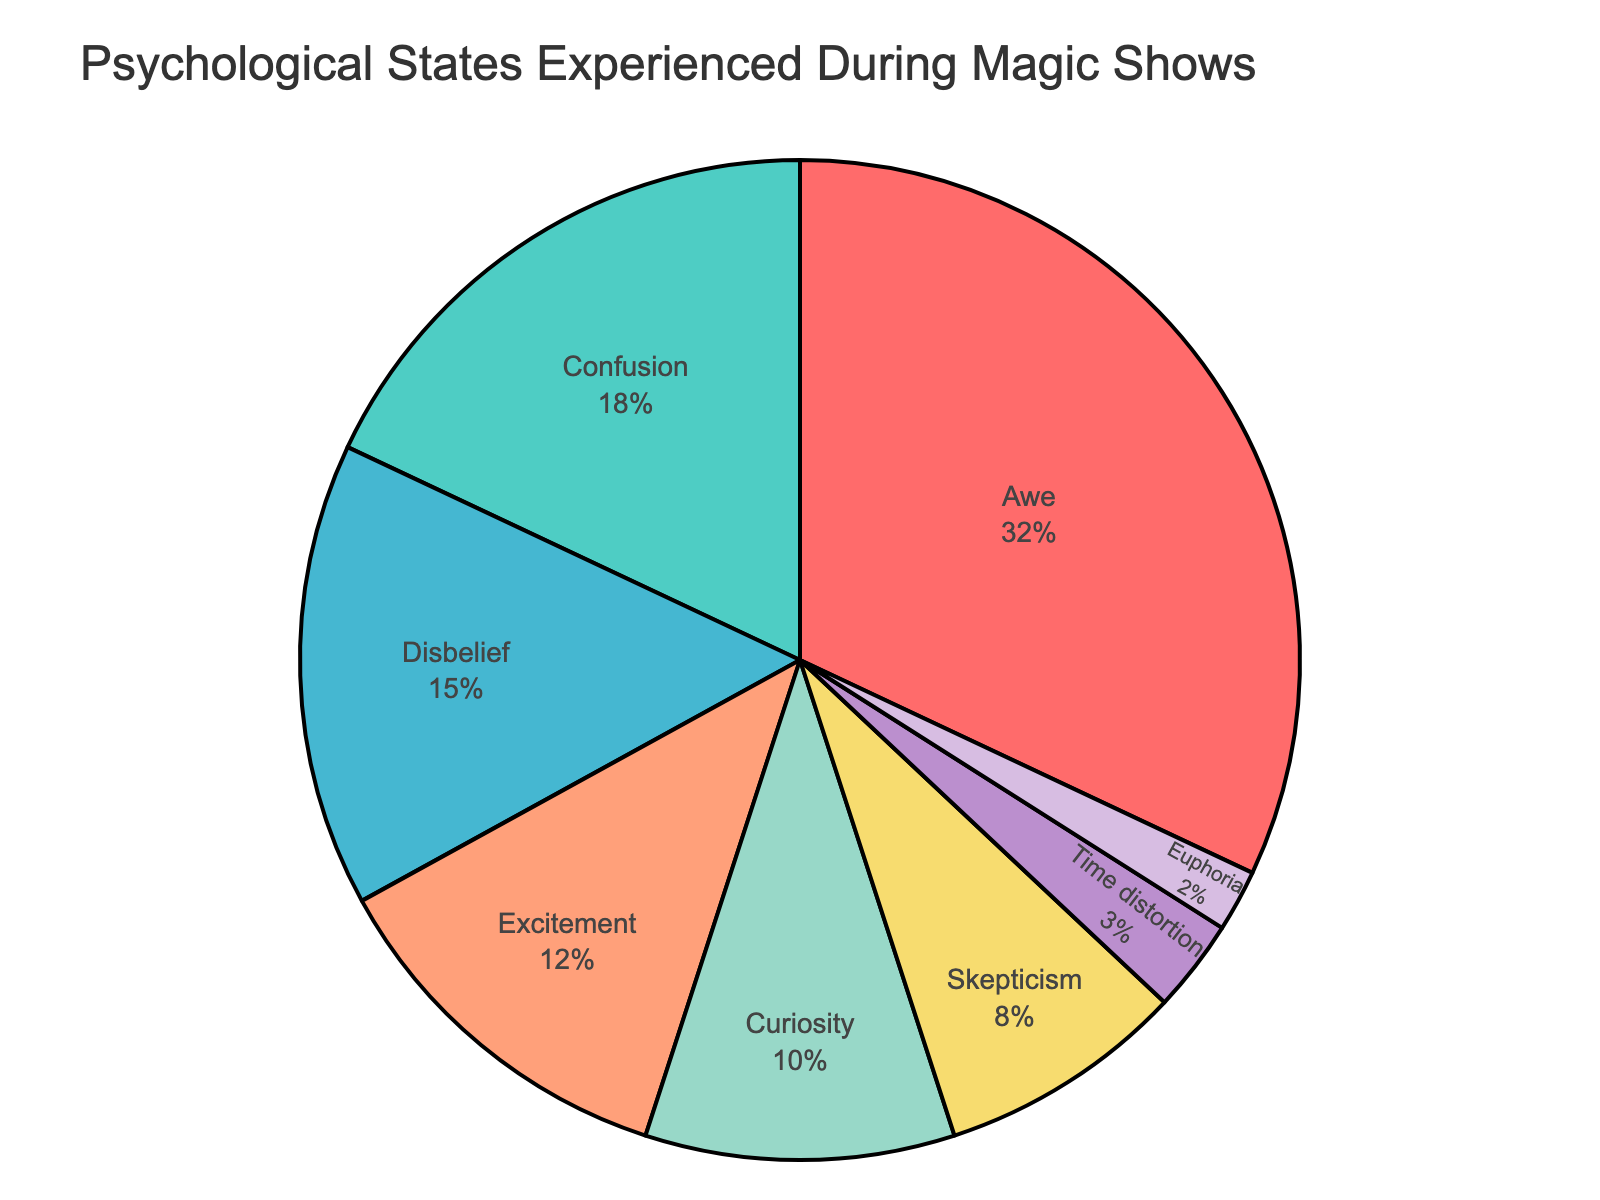What is the most commonly reported psychological state experienced during magic shows? The figure shows that 'Awe' has the largest slice in the pie chart with a percentage of 32%, which is the highest among all states reported.
Answer: Awe What is the combined percentage of audience members who report experiencing 'Confusion' and 'Disbelief'? We look at the data in the pie chart, where 'Confusion' is 18% and 'Disbelief' is 15%. Adding these percentages gives 18% + 15% = 33%.
Answer: 33% Which psychological state has a percentage twice that of 'Curiosity'? The figure indicates that 'Curiosity' is at 10%. The state with double this percentage is 'Awe', which is at 32% (nearest to double of 10% is 20%, and only 'Awe' and 'Confusion' are higher). However, 'Awe' at 32% is closer to double 10% compared to 'Confusion' at 18%.
Answer: Awe What is the percentage difference between 'Excitement' and 'Skepticism'? According to the pie chart, 'Excitement' is 12% and 'Skepticism' is 8%. The percentage difference is 12% - 8% = 4%.
Answer: 4% How many psychological states are reported by less than 10% of the audience members? Referring to the pie chart, 'Curiosity' (10%), 'Skepticism' (8%), 'Time distortion' (3%), and 'Euphoria' (2%) are the states less than 10%. This sums to four states.
Answer: 4 Which psychological state has a larger percentage, 'Euphoria' or 'Time distortion'? The figure shows that 'Time distortion' has 3% whereas 'Euphoria' has 2%. Therefore, 'Time distortion' has a larger percentage.
Answer: Time distortion What percentage of audience members report experiencing 'Skepticism' and how does it visually compare in size to 'Confusion' in the pie chart? The pie chart shows 'Skepticism' at 8% and 'Confusion' at 18%. Visually, 'Skepticism' has a smaller slice than 'Confusion'.
Answer: 8%; 'Skepticism' is smaller than 'Confusion' If the 'Excitement' and 'Curiosity' slices were combined, would their total percentage be greater than 'Awe'? According to the pie chart, 'Excitement' is 12% and 'Curiosity' is 10%. Combined, 12% + 10% = 22%, which is less than 'Awe' at 32%.
Answer: No 